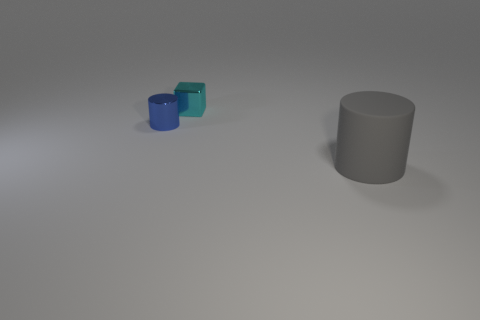Does the blue shiny thing have the same size as the cylinder on the right side of the cyan metal block?
Provide a short and direct response. No. What number of objects are cylinders behind the large gray cylinder or large brown matte cubes?
Your answer should be compact. 1. What is the shape of the tiny object that is on the right side of the tiny metallic cylinder?
Provide a short and direct response. Cube. Are there the same number of blue shiny cylinders behind the tiny cyan object and small shiny things that are to the left of the shiny cylinder?
Keep it short and to the point. Yes. There is a thing that is both left of the matte cylinder and on the right side of the blue cylinder; what color is it?
Your response must be concise. Cyan. What material is the cylinder that is to the right of the small metal object that is on the left side of the cyan object made of?
Provide a succinct answer. Rubber. Do the cyan block and the blue object have the same size?
Ensure brevity in your answer.  Yes. How many big things are either gray objects or blue metal cylinders?
Offer a terse response. 1. What number of small cyan things are on the left side of the large matte thing?
Your answer should be very brief. 1. Are there more gray matte things on the left side of the metallic cylinder than big purple shiny cylinders?
Offer a terse response. No. 